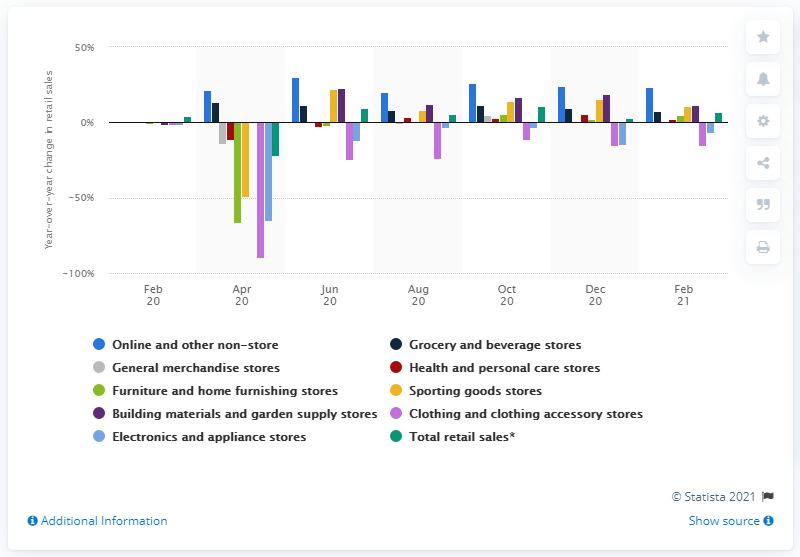List a handful of essential elements in this visual. In February 2021, the sales of the sporting goods store increased by 11.4%. Total retail sales in the United States increased by 7.1% in February 2021, according to the latest data. 